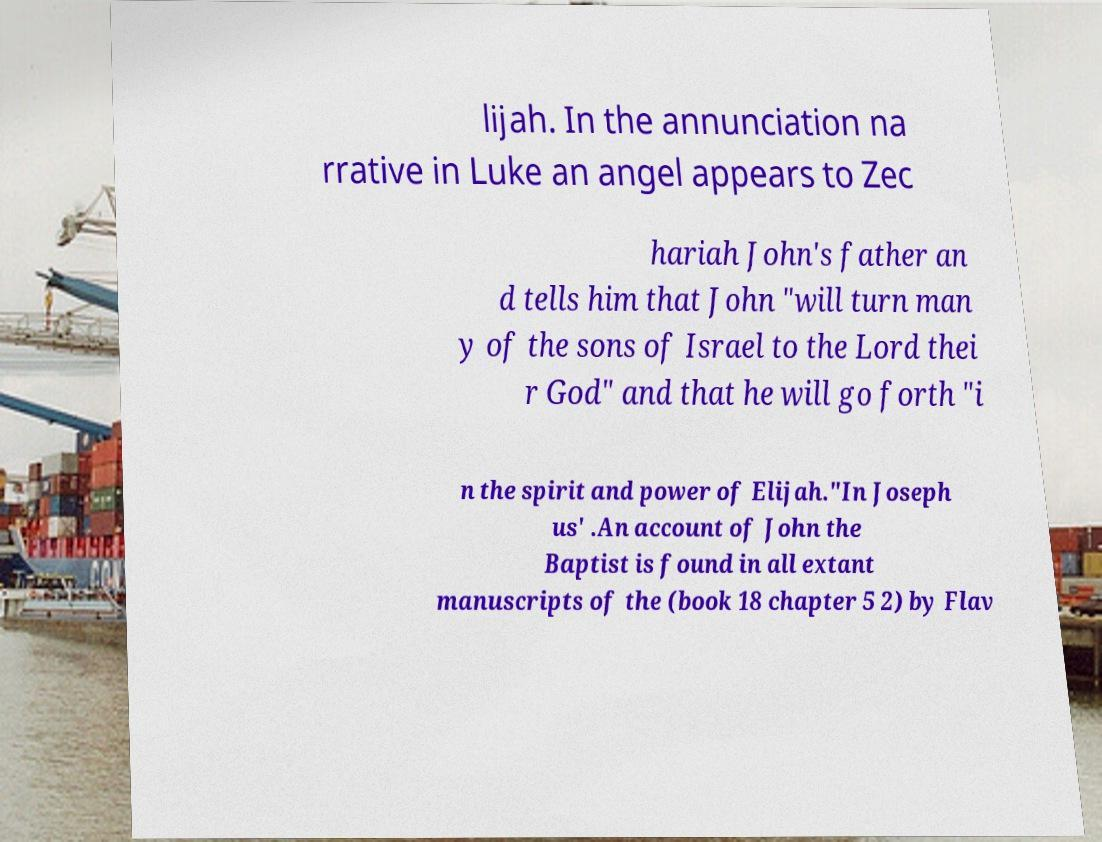Could you extract and type out the text from this image? lijah. In the annunciation na rrative in Luke an angel appears to Zec hariah John's father an d tells him that John "will turn man y of the sons of Israel to the Lord thei r God" and that he will go forth "i n the spirit and power of Elijah."In Joseph us' .An account of John the Baptist is found in all extant manuscripts of the (book 18 chapter 5 2) by Flav 